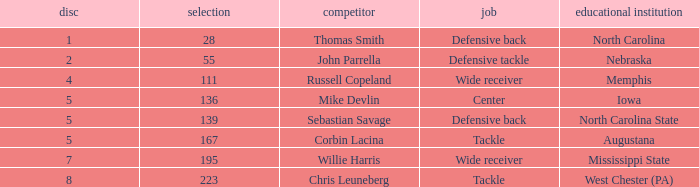What is the sum of Round with a Position that is center? 5.0. 